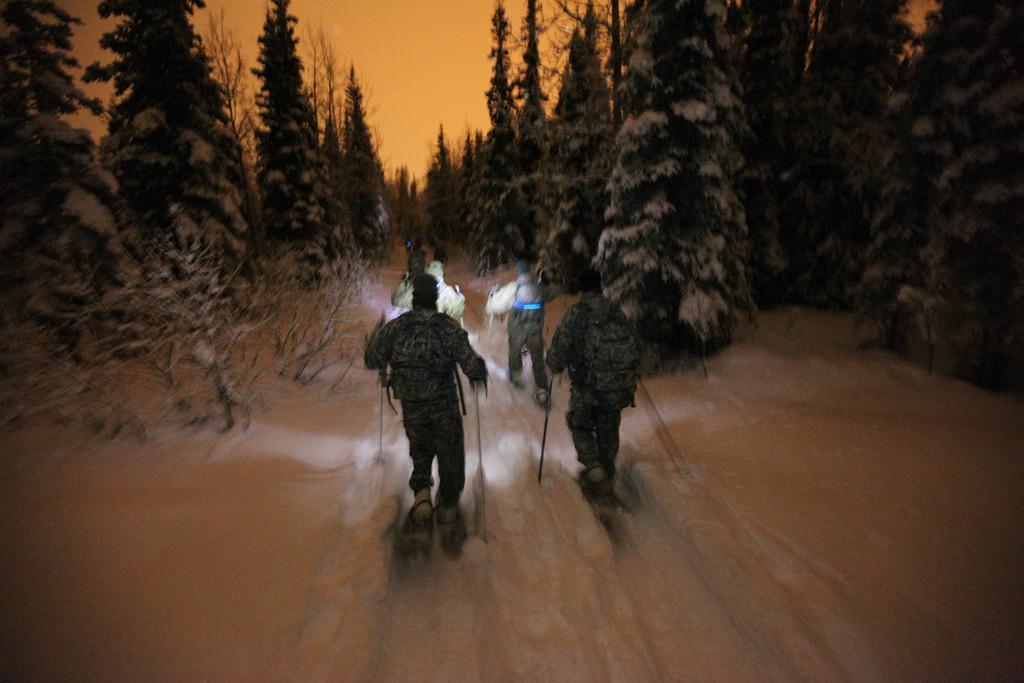Can you describe this image briefly? This is an edited image. In this picture, we see the men in the uniform are holding the skiing sticks in their hands and they are skiing. At the bottom, we see the snow. There are trees in the background and these trees are covered with the snow. At the top, we see the sky. 